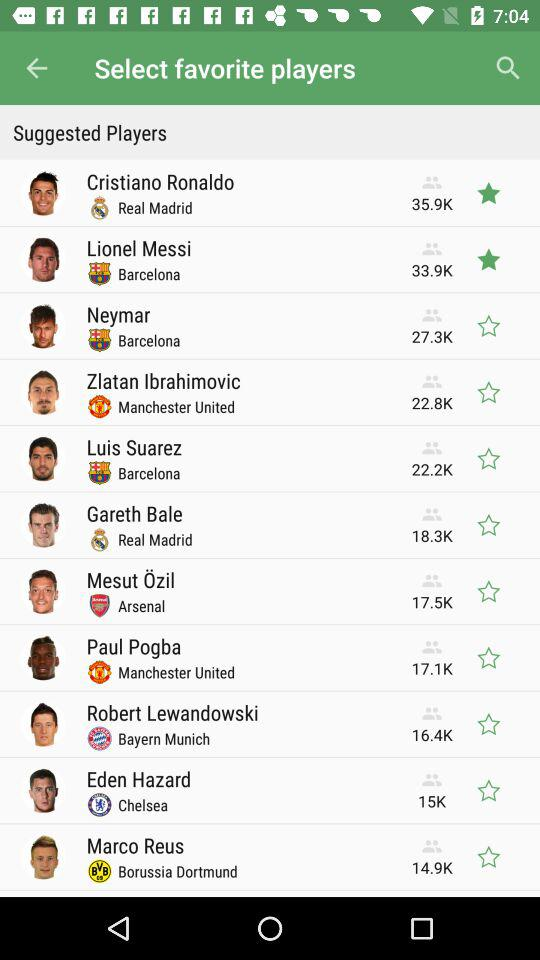Which players are not selected? The unselected players are Neymar, Zlatan Ibrahimovic, Luis Suarez, Gareth Bale, Mesut Özil, Paul Pogba, Robert Lewandowski, Eden Hazard and Marco Reus. 